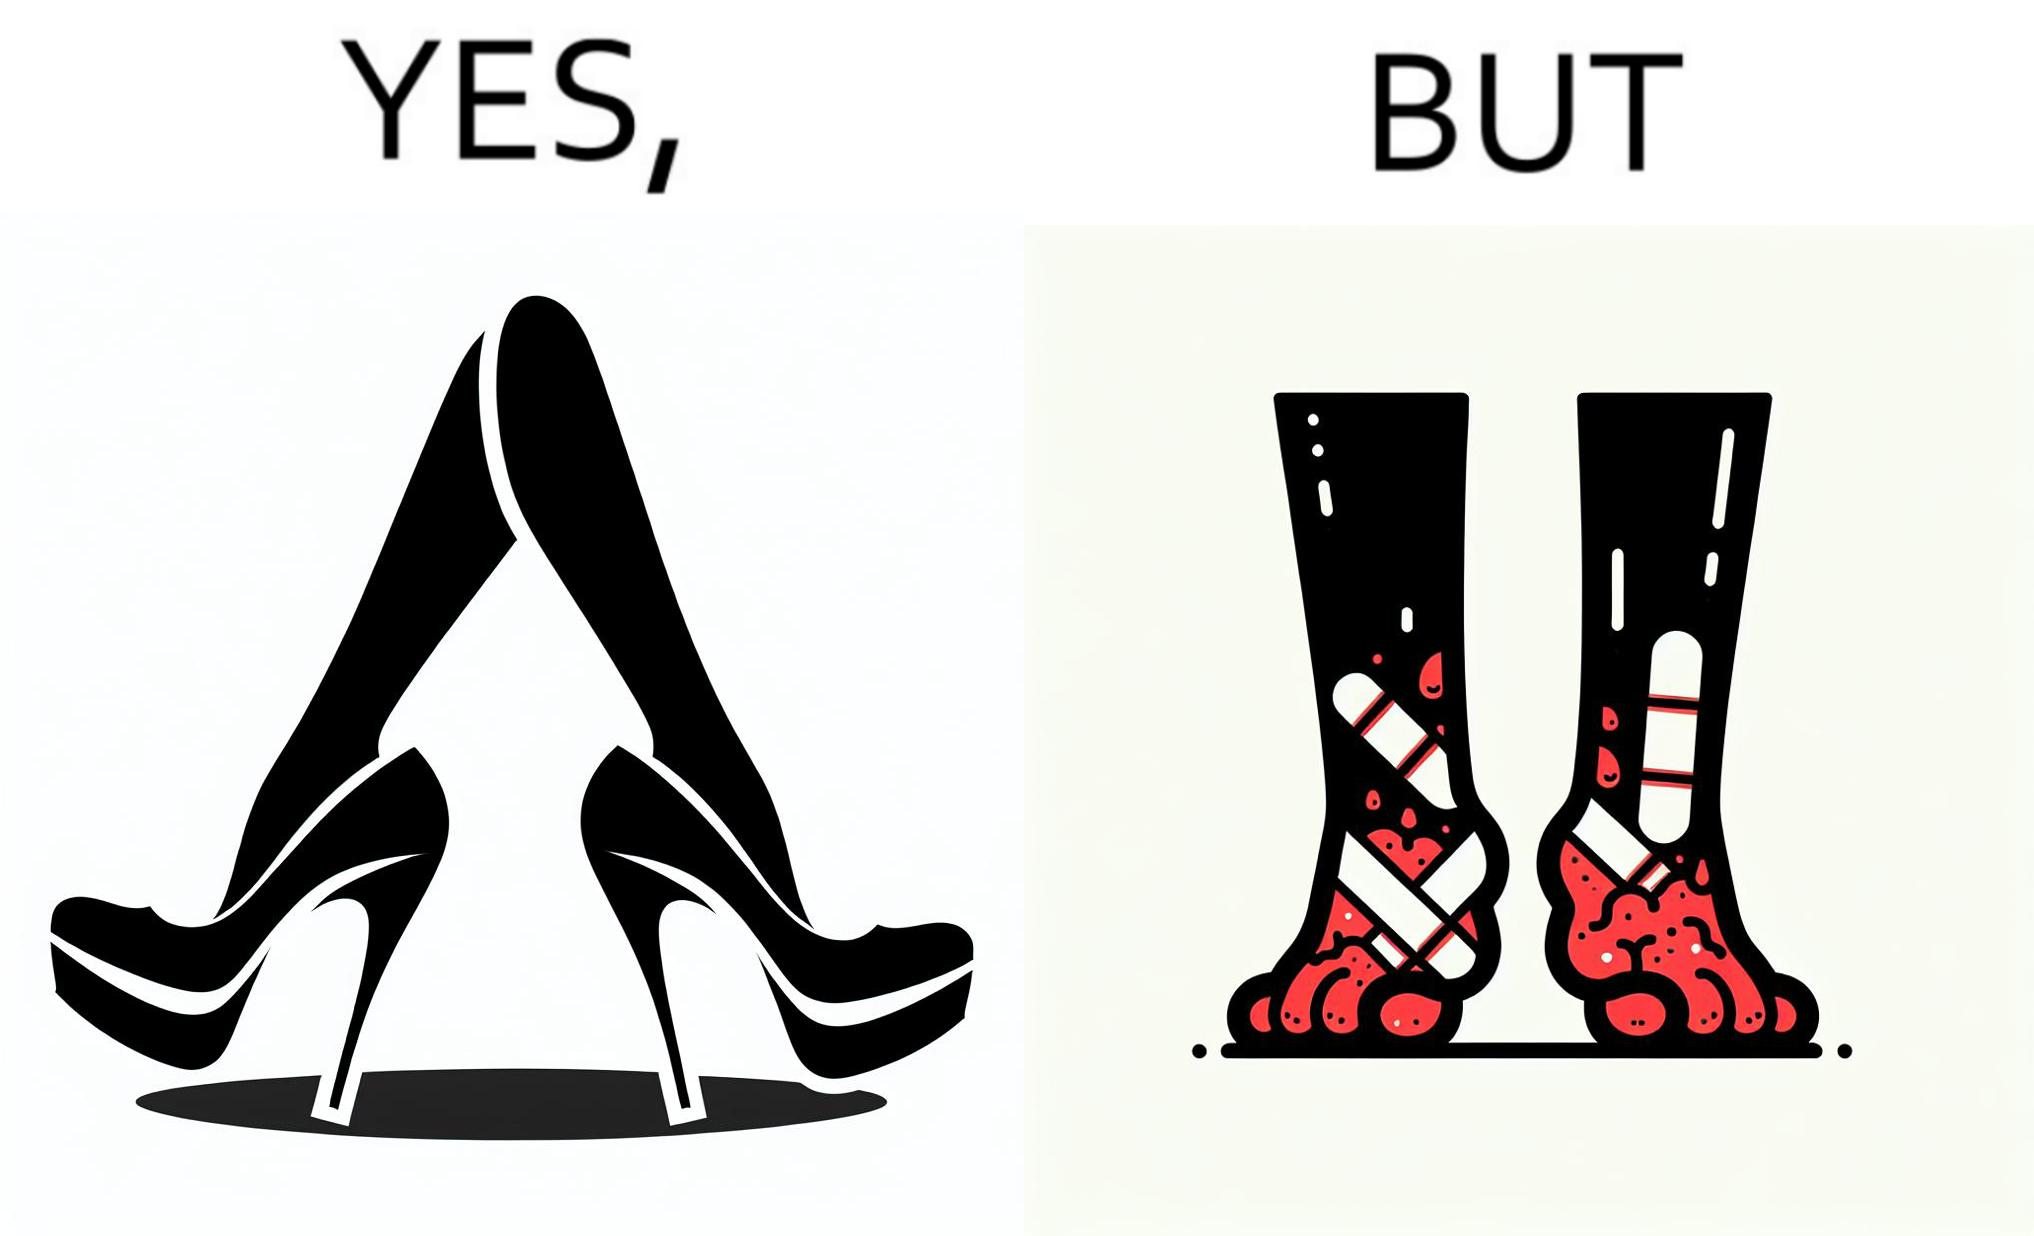What is shown in the left half versus the right half of this image? In the left part of the image: a pair of high heeled shoes In the right part of the image: A pair of feet, blistered and red, with bandages 